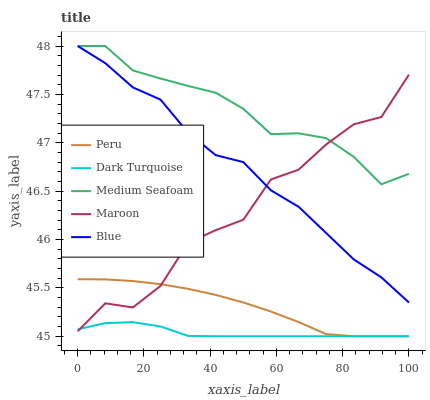Does Dark Turquoise have the minimum area under the curve?
Answer yes or no. Yes. Does Medium Seafoam have the maximum area under the curve?
Answer yes or no. Yes. Does Medium Seafoam have the minimum area under the curve?
Answer yes or no. No. Does Dark Turquoise have the maximum area under the curve?
Answer yes or no. No. Is Peru the smoothest?
Answer yes or no. Yes. Is Maroon the roughest?
Answer yes or no. Yes. Is Dark Turquoise the smoothest?
Answer yes or no. No. Is Dark Turquoise the roughest?
Answer yes or no. No. Does Medium Seafoam have the lowest value?
Answer yes or no. No. Does Blue have the highest value?
Answer yes or no. Yes. Does Dark Turquoise have the highest value?
Answer yes or no. No. Is Dark Turquoise less than Blue?
Answer yes or no. Yes. Is Medium Seafoam greater than Peru?
Answer yes or no. Yes. Does Peru intersect Dark Turquoise?
Answer yes or no. Yes. Is Peru less than Dark Turquoise?
Answer yes or no. No. Is Peru greater than Dark Turquoise?
Answer yes or no. No. Does Dark Turquoise intersect Blue?
Answer yes or no. No. 